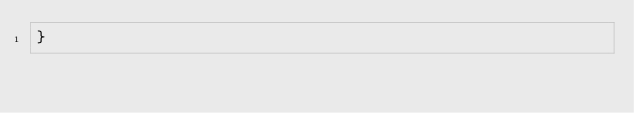Convert code to text. <code><loc_0><loc_0><loc_500><loc_500><_CSS_>}</code> 